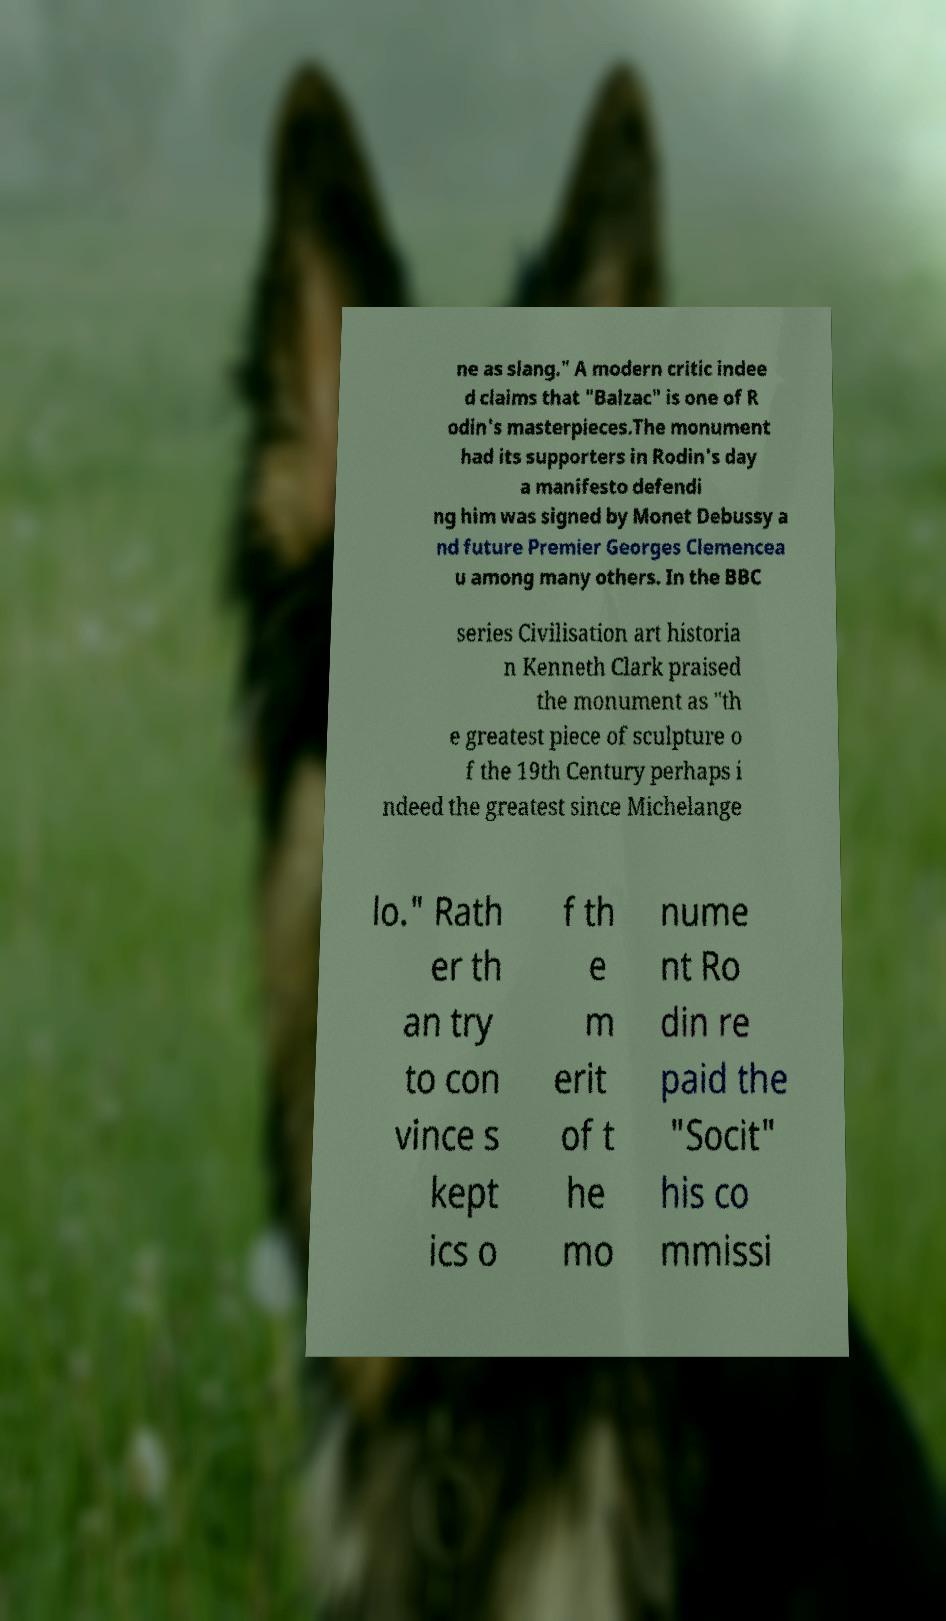For documentation purposes, I need the text within this image transcribed. Could you provide that? ne as slang." A modern critic indee d claims that "Balzac" is one of R odin's masterpieces.The monument had its supporters in Rodin's day a manifesto defendi ng him was signed by Monet Debussy a nd future Premier Georges Clemencea u among many others. In the BBC series Civilisation art historia n Kenneth Clark praised the monument as "th e greatest piece of sculpture o f the 19th Century perhaps i ndeed the greatest since Michelange lo." Rath er th an try to con vince s kept ics o f th e m erit of t he mo nume nt Ro din re paid the "Socit" his co mmissi 